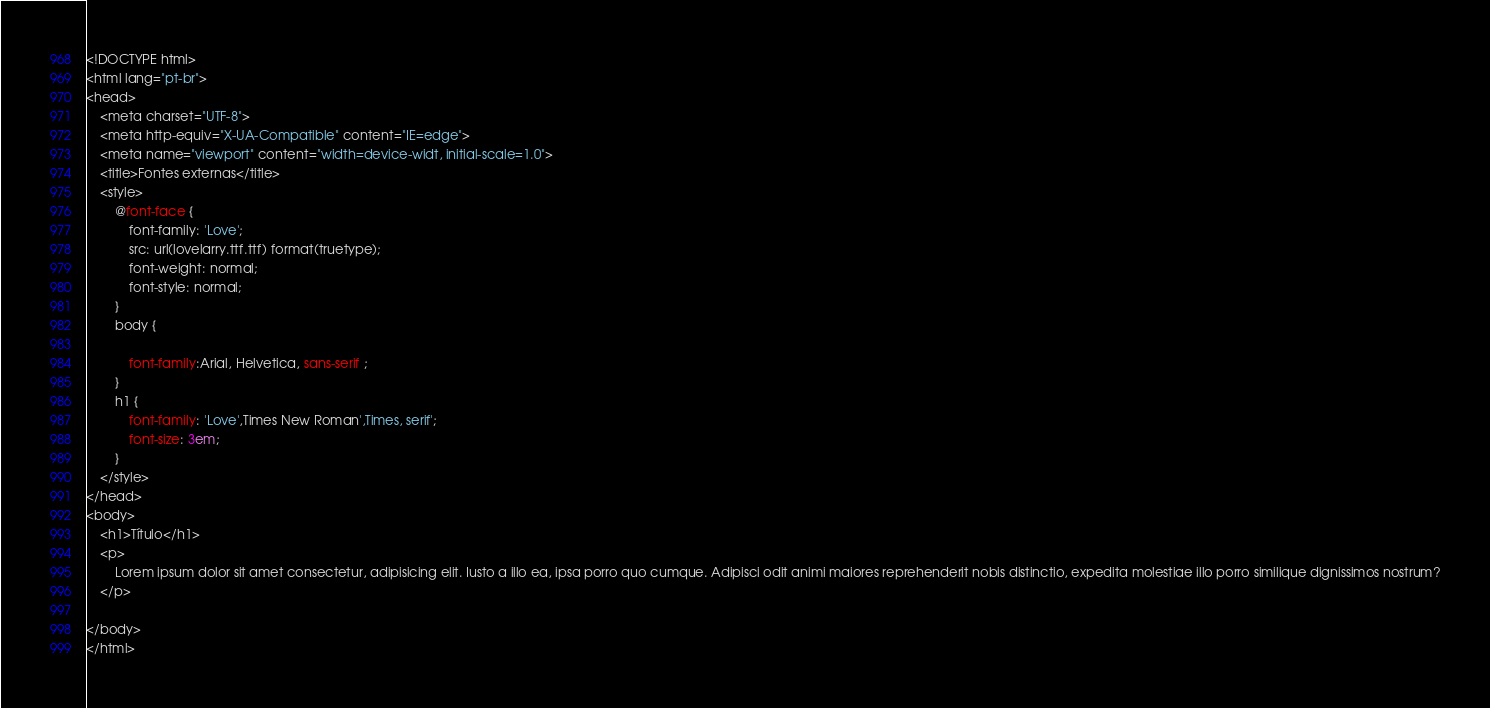Convert code to text. <code><loc_0><loc_0><loc_500><loc_500><_HTML_><!DOCTYPE html>
<html lang="pt-br">
<head>
    <meta charset="UTF-8">
    <meta http-equiv="X-UA-Compatible" content="IE=edge">
    <meta name="viewport" content="width=device-widt, initial-scale=1.0">
    <title>Fontes externas</title>
    <style>
        @font-face {
            font-family: 'Love';
            src: url(lovelarry.ttf.ttf) format(truetype);
            font-weight: normal;
            font-style: normal;
        }
        body {

            font-family:Arial, Helvetica, sans-serif ;
        }
        h1 {
            font-family: 'Love',Times New Roman',Times, serif';
            font-size: 3em;
        }
    </style>
</head>
<body>
    <h1>Título</h1>
    <p>
        Lorem ipsum dolor sit amet consectetur, adipisicing elit. Iusto a illo ea, ipsa porro quo cumque. Adipisci odit animi maiores reprehenderit nobis distinctio, expedita molestiae illo porro similique dignissimos nostrum?
    </p>

</body>
</html></code> 